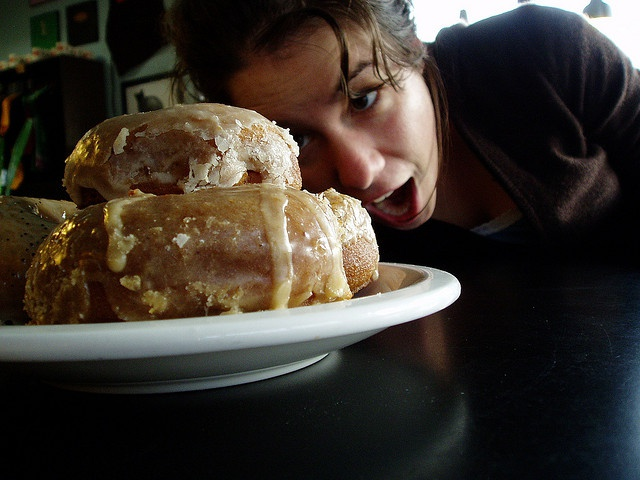Describe the objects in this image and their specific colors. I can see people in black, maroon, and gray tones, dining table in black, gray, and purple tones, dining table in black, navy, blue, and maroon tones, donut in black, maroon, olive, and tan tones, and donut in black, maroon, olive, and tan tones in this image. 